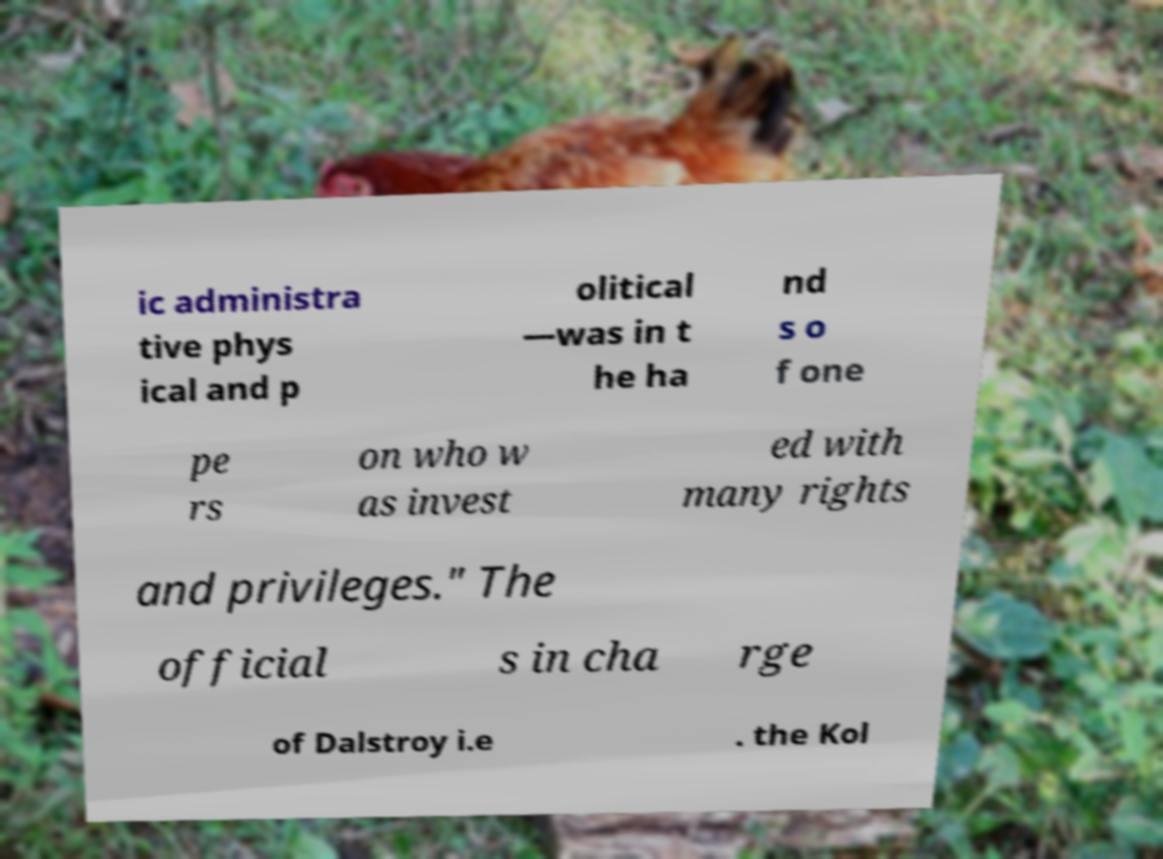Could you extract and type out the text from this image? ic administra tive phys ical and p olitical —was in t he ha nd s o f one pe rs on who w as invest ed with many rights and privileges." The official s in cha rge of Dalstroy i.e . the Kol 